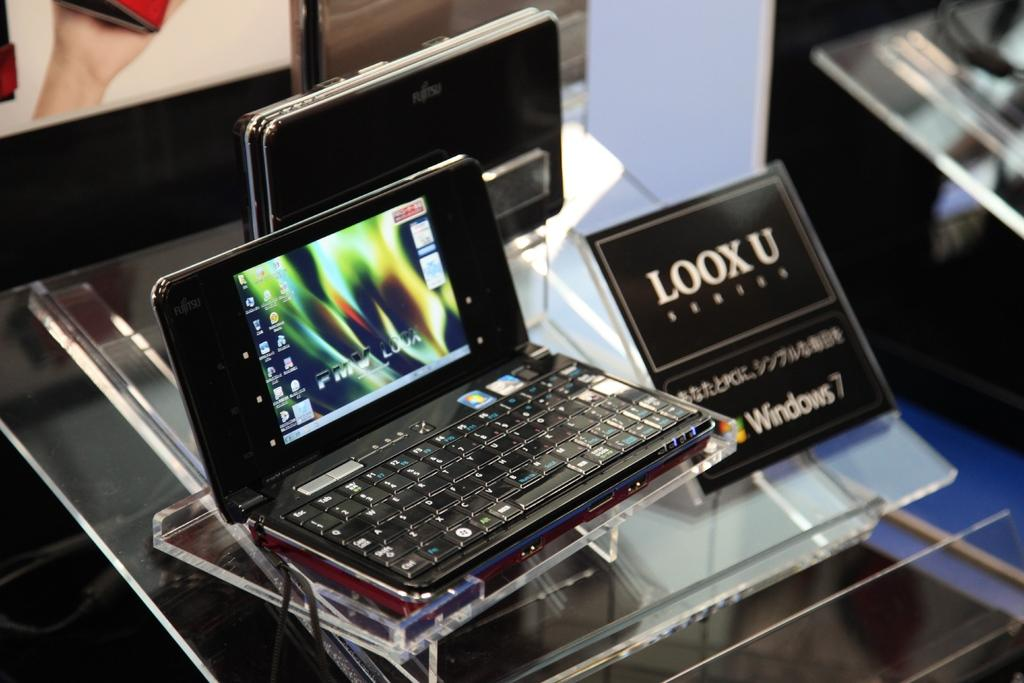<image>
Render a clear and concise summary of the photo. A Windows 7 display with a computer next to it. 